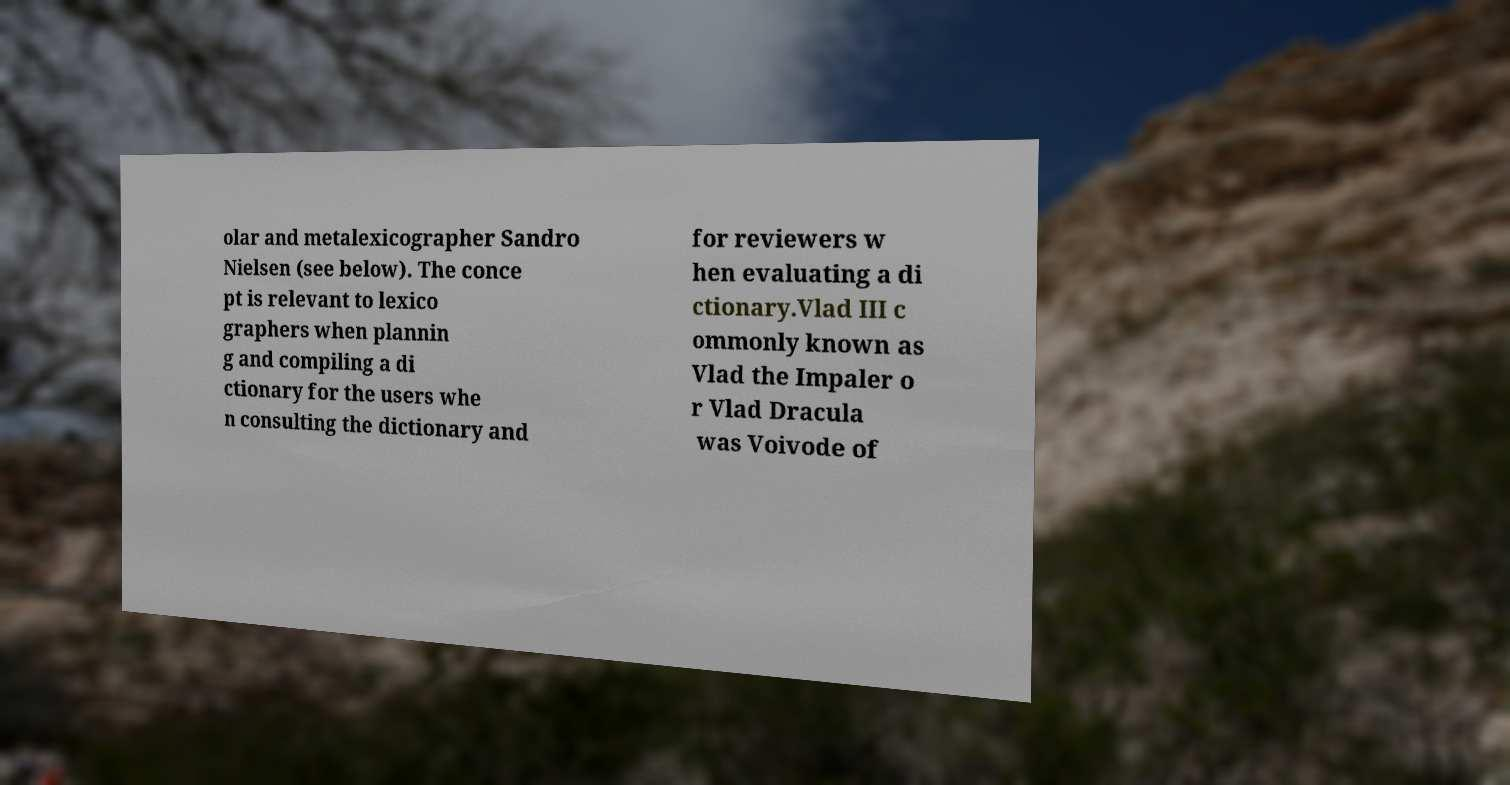I need the written content from this picture converted into text. Can you do that? olar and metalexicographer Sandro Nielsen (see below). The conce pt is relevant to lexico graphers when plannin g and compiling a di ctionary for the users whe n consulting the dictionary and for reviewers w hen evaluating a di ctionary.Vlad III c ommonly known as Vlad the Impaler o r Vlad Dracula was Voivode of 